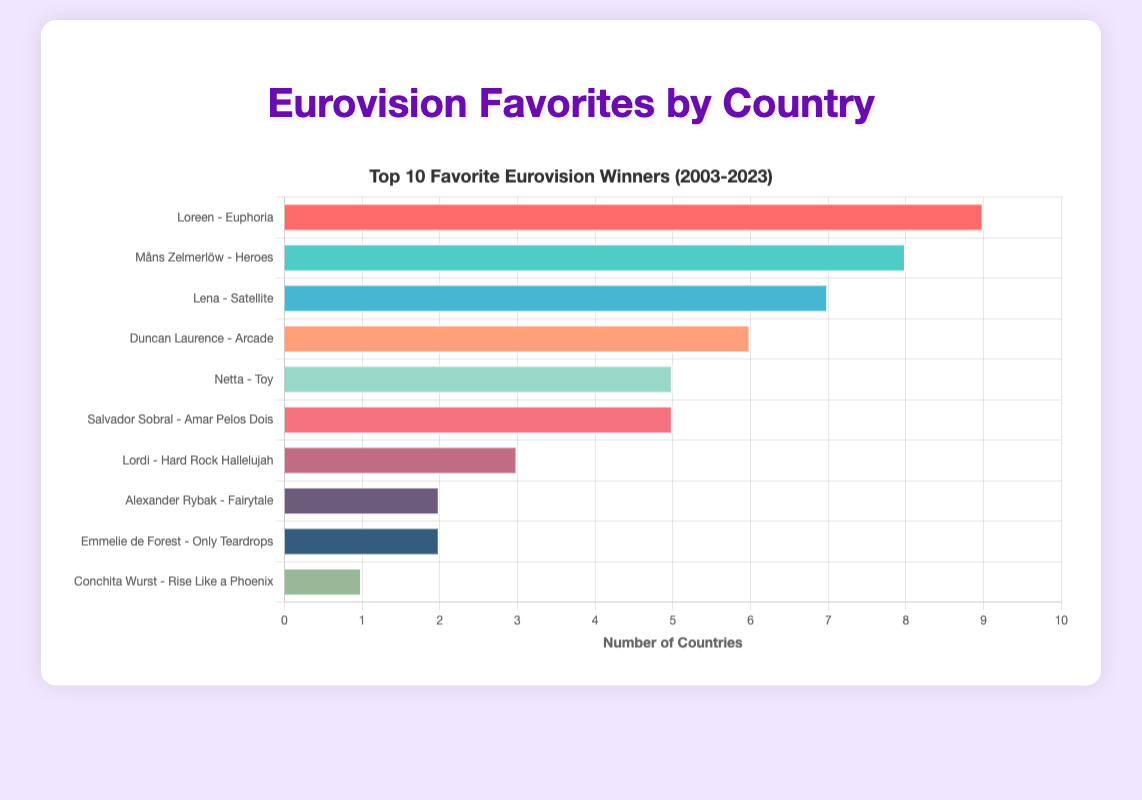What is the most favorite Eurovision winner based on the number of countries? First, count the number of countries that have selected each winner as their favorite. Loreen's "Euphoria" is the most mentioned winner across multiple countries.
Answer: Loreen - Euphoria How many countries have "Heroes" by Måns Zelmerlöw as their favorite? Count the number of countries that have selected Måns Zelmerlöw's "Heroes" as their favorite Eurovision winner.
Answer: 8 What is the difference in the number of countries between the favorites "Euphoria" by Loreen and "Fairytale" by Alexander Rybak? According to the chart, "Euphoria" by Loreen is a favorite in 10 countries and "Fairytale" in 2 countries. The difference is 10 - 2.
Answer: 8 How many songs are favored by at least 5 countries? Count the number of songs in the bar chart that have bars reaching at least up to the number 5 on the x-axis.
Answer: 5 Which song has the second-highest number of favorite selections among the countries? Identify the second tallest bar in the chart after counting the bars. "Heroes" by Måns Zelmerlöw has the second-highest number of favorite selections.
Answer: Måns Zelmerlöw - Heroes How does the count of Madonna's "Euphoria" compare to Duncan Laurence's "Arcade"? Look at the bars representing Loreen's "Euphoria" and Duncan Laurence's "Arcade" and compare their lengths. Loreen's "Euphoria" is a favorite in 10 countries, while Duncan Laurence's "Arcade" is favored in 6 countries.
Answer: "Euphoria" is favored by more countries Among "Satellite" by Lena and "Toy" by Netta, which has more country favorites, and by how much? Look at the lengths of the bars for "Satellite" by Lena and "Toy" by Netta. "Satellite" by Lena is a favorite in 6 countries, and "Toy" by Netta is a favorite in 4, thus the difference is 6 - 4.
Answer: "Satellite" by 2 Which favorite song from the chart has the fewest country selections? Identify the shortest bar in the chart. There is a tie, but "Rise Like a Phoenix" by Conchita Wurst and "Only Teardrops" by Emmelie de Forest are among the shortest, each favored by 2 countries.
Answer: "Rise Like a Phoenix" and "Only Teardrops" What is the sum of the countries that preferred "Euphoria" by Loreen, "Toy" by Netta, and "Amar Pelos Dois" by Salvador Sobral? Count the number of countries for "Euphoria" (10), "Toy" (4), and "Amar Pelos Dois" (5) and sum them (10 + 4 + 5).
Answer: 19 